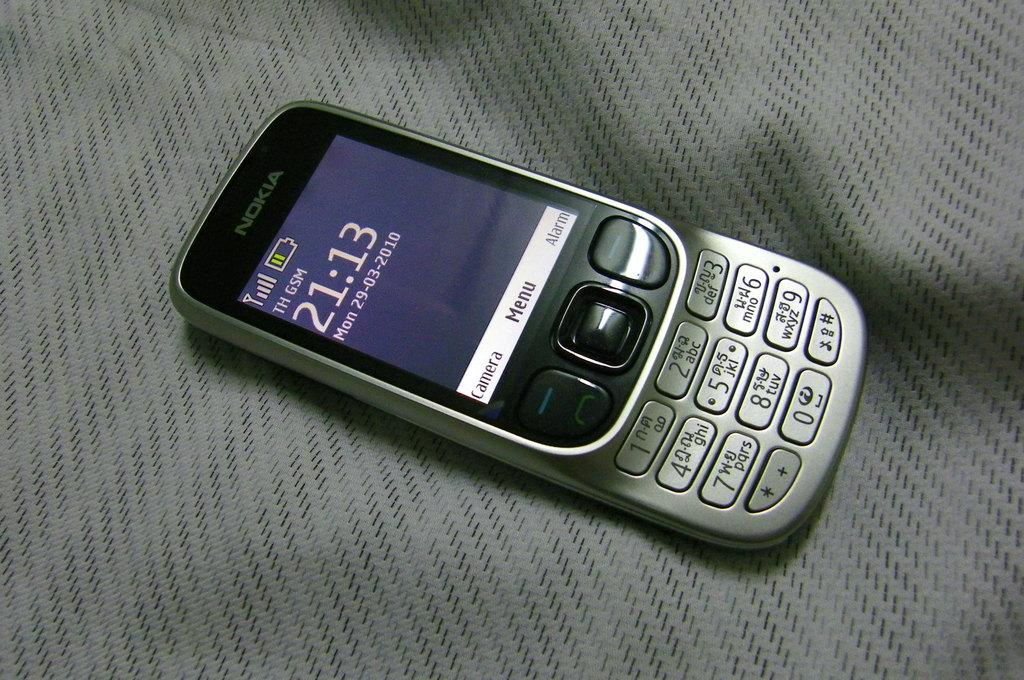<image>
Offer a succinct explanation of the picture presented. An old phone made by Nokia is on the sheets. 